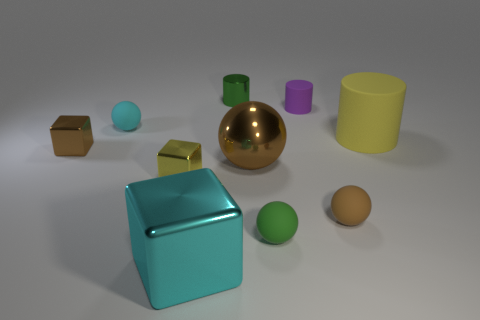There is a brown ball behind the yellow object in front of the large object behind the brown shiny sphere; what is it made of?
Your answer should be compact. Metal. What is the size of the rubber sphere that is behind the tiny green sphere and to the right of the big ball?
Offer a very short reply. Small. Do the big brown thing and the purple thing have the same shape?
Keep it short and to the point. No. What shape is the small green thing that is the same material as the small brown block?
Give a very brief answer. Cylinder. What number of small things are yellow cylinders or purple objects?
Your answer should be compact. 1. There is a brown rubber thing that is in front of the tiny cyan object; are there any big shiny things that are behind it?
Provide a short and direct response. Yes. Is there a small purple rubber cylinder?
Your answer should be very brief. Yes. There is a metal object that is on the left side of the tiny ball left of the large metal block; what is its color?
Offer a terse response. Brown. There is another large object that is the same shape as the brown rubber object; what is it made of?
Give a very brief answer. Metal. What number of green rubber things are the same size as the yellow rubber cylinder?
Your answer should be compact. 0. 